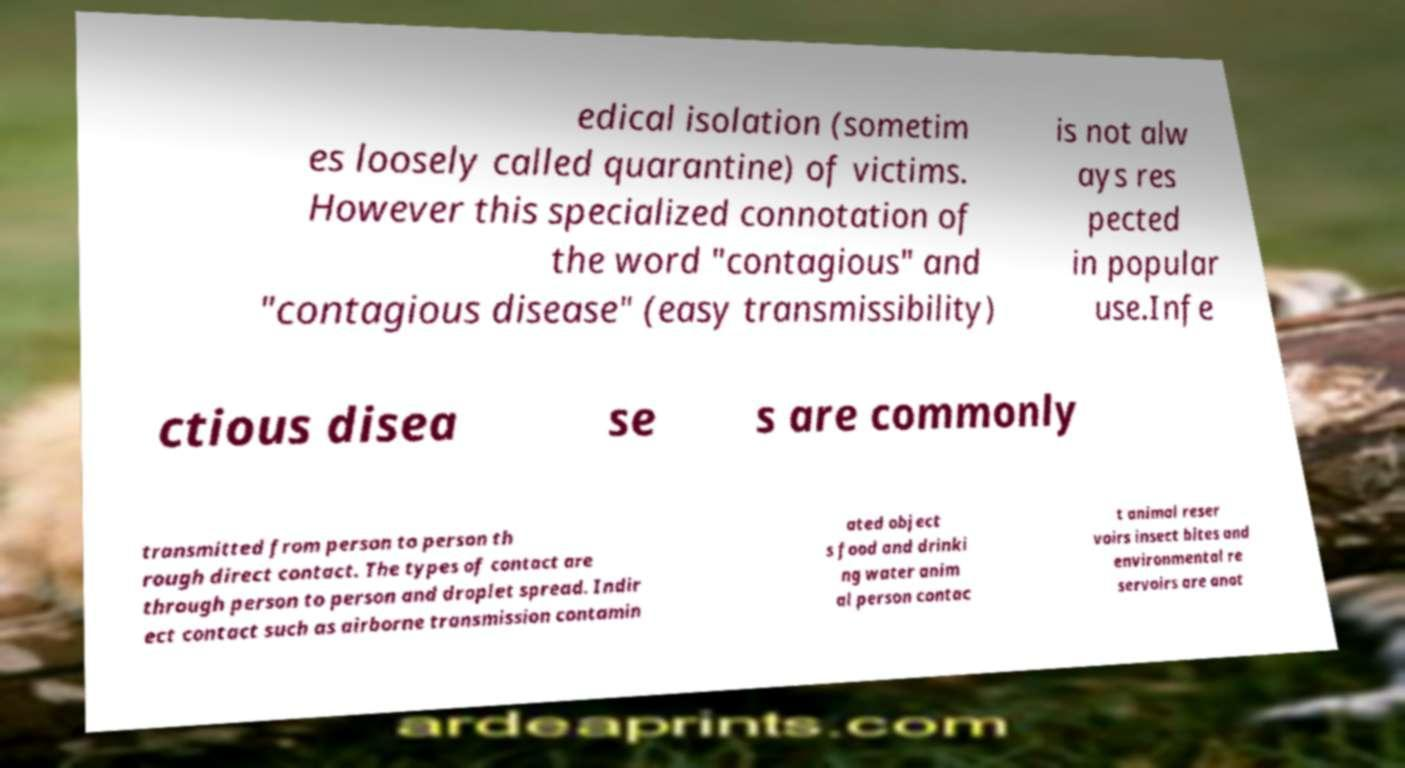There's text embedded in this image that I need extracted. Can you transcribe it verbatim? edical isolation (sometim es loosely called quarantine) of victims. However this specialized connotation of the word "contagious" and "contagious disease" (easy transmissibility) is not alw ays res pected in popular use.Infe ctious disea se s are commonly transmitted from person to person th rough direct contact. The types of contact are through person to person and droplet spread. Indir ect contact such as airborne transmission contamin ated object s food and drinki ng water anim al person contac t animal reser voirs insect bites and environmental re servoirs are anot 